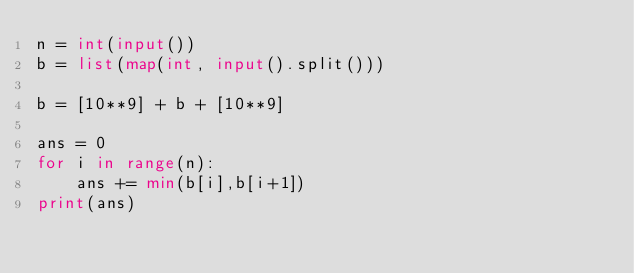<code> <loc_0><loc_0><loc_500><loc_500><_Python_>n = int(input())
b = list(map(int, input().split()))

b = [10**9] + b + [10**9]

ans = 0
for i in range(n):
    ans += min(b[i],b[i+1])
print(ans)</code> 